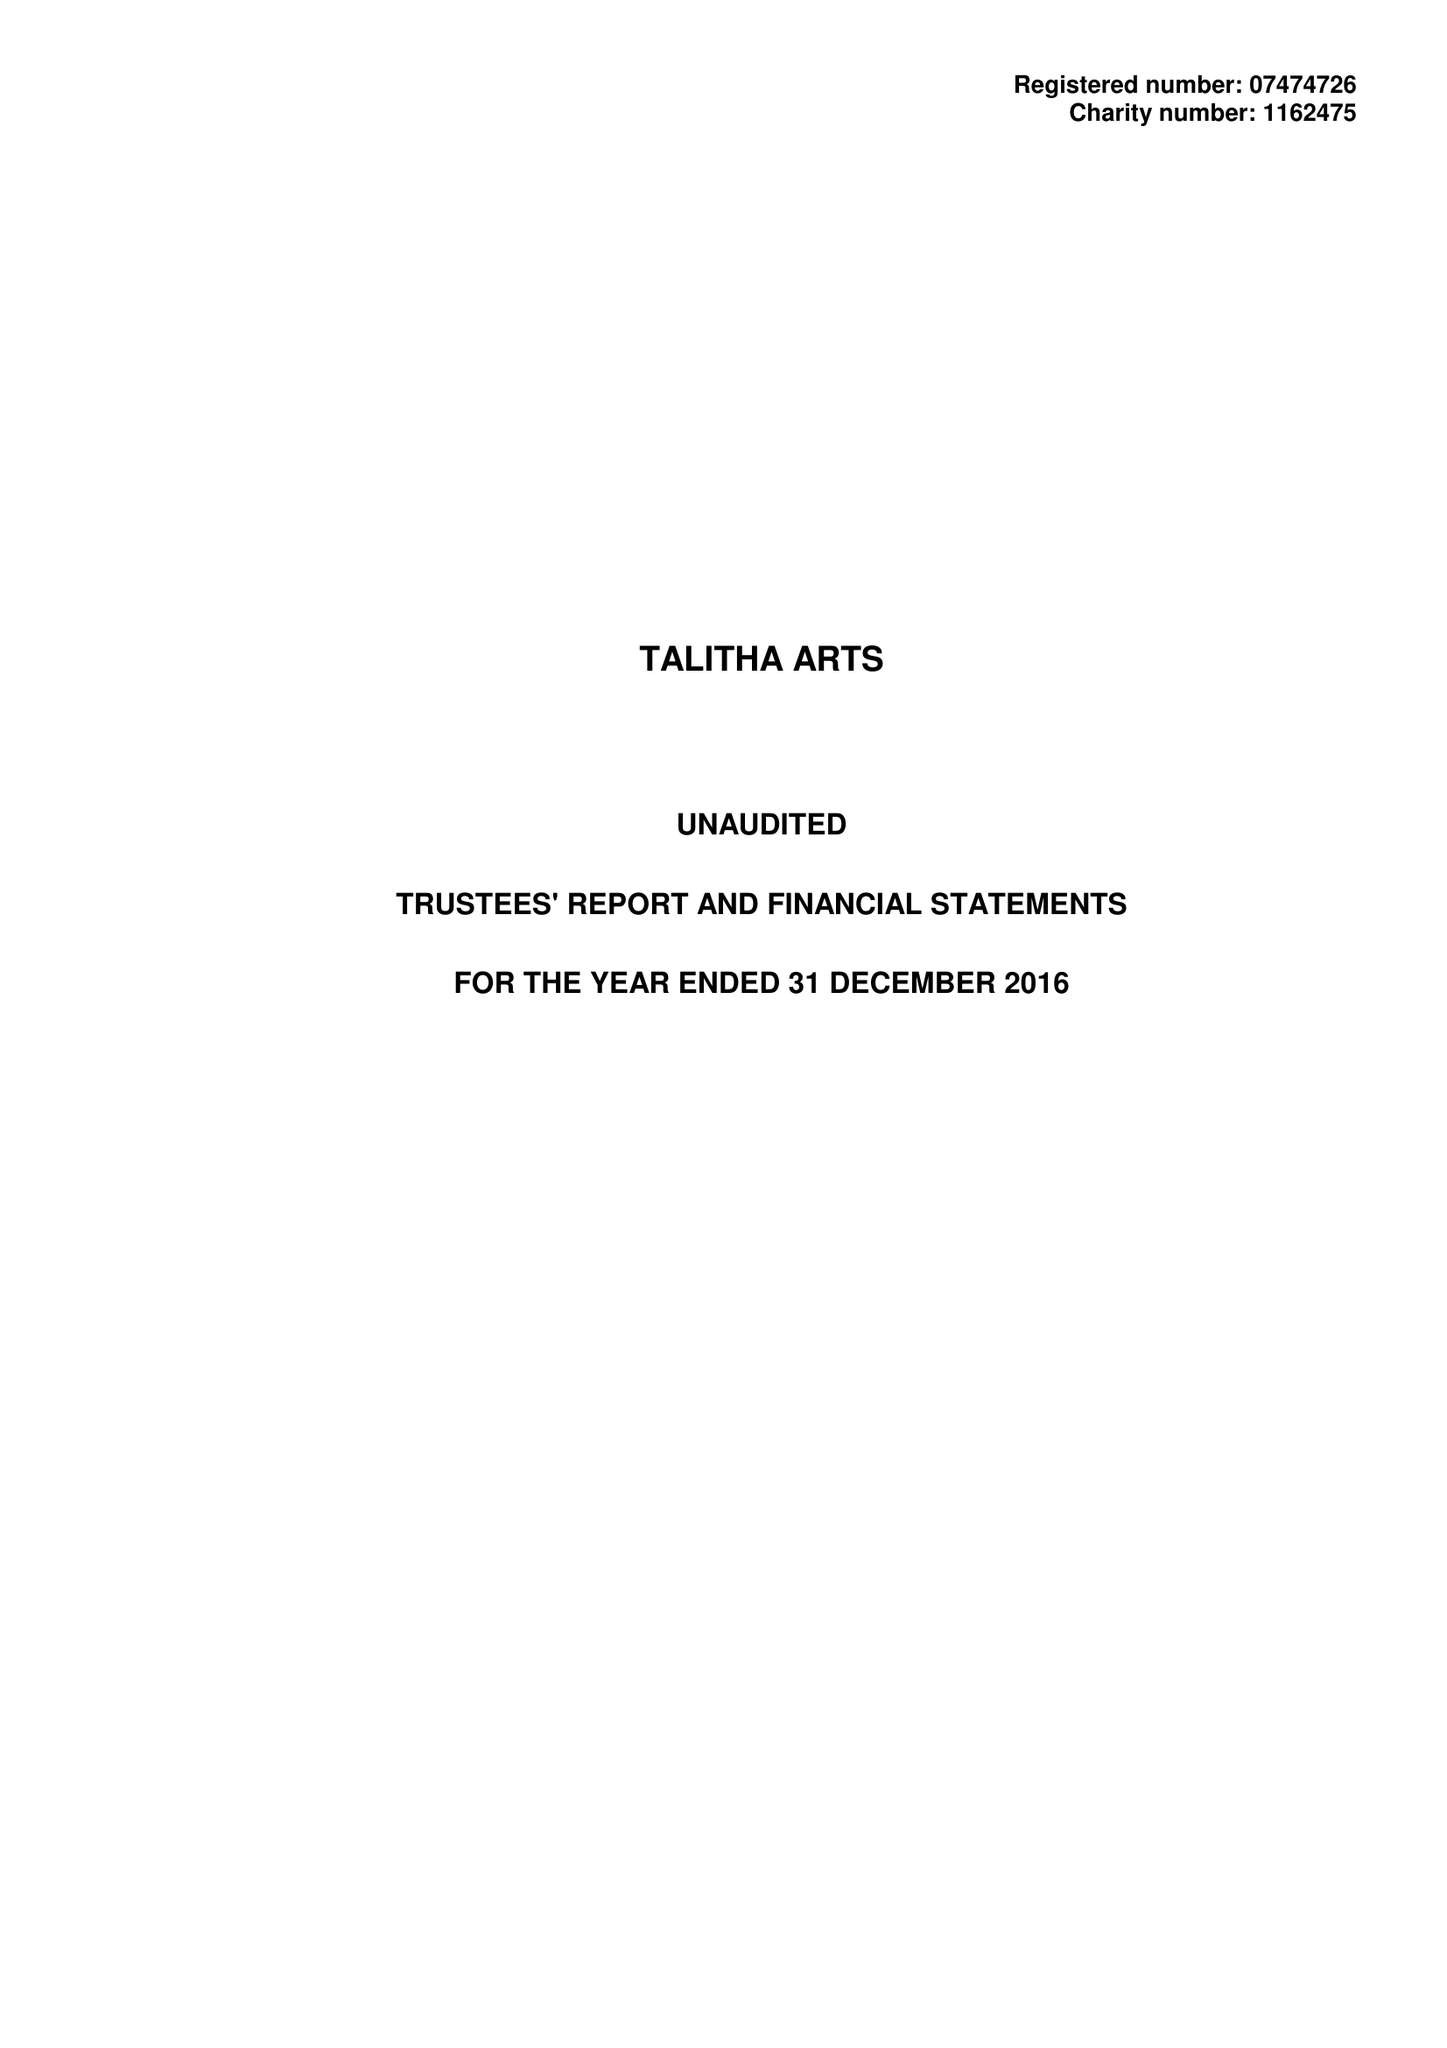What is the value for the charity_number?
Answer the question using a single word or phrase. 1162475 